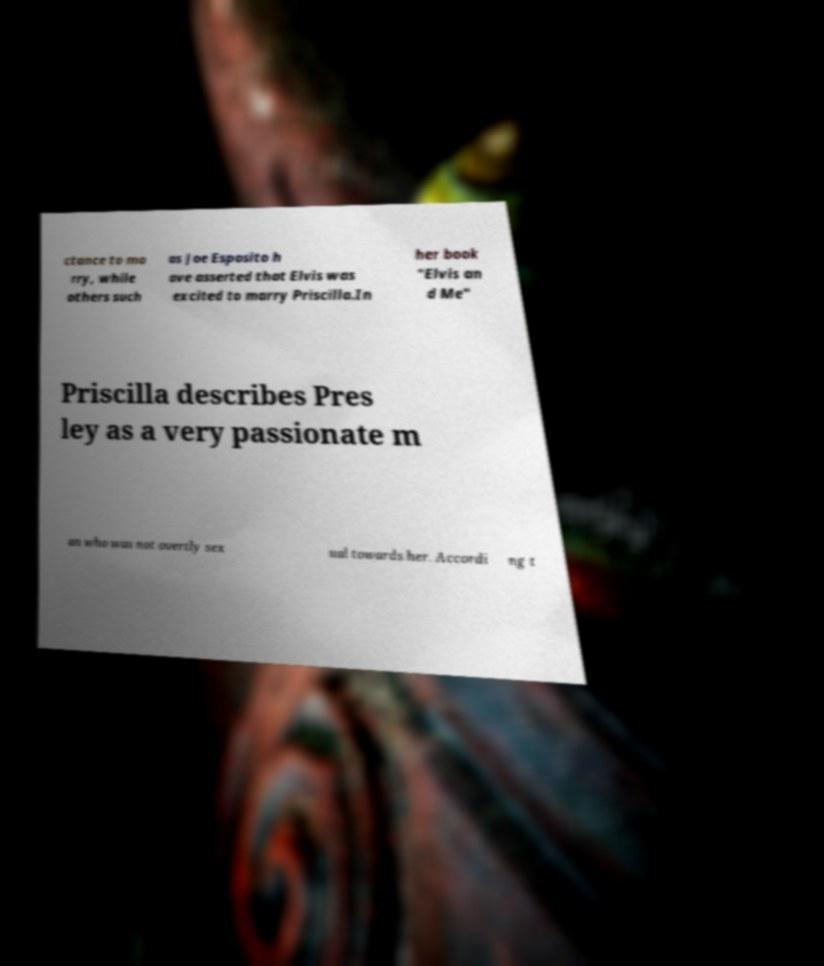Could you assist in decoding the text presented in this image and type it out clearly? ctance to ma rry, while others such as Joe Esposito h ave asserted that Elvis was excited to marry Priscilla.In her book "Elvis an d Me" Priscilla describes Pres ley as a very passionate m an who was not overtly sex ual towards her. Accordi ng t 